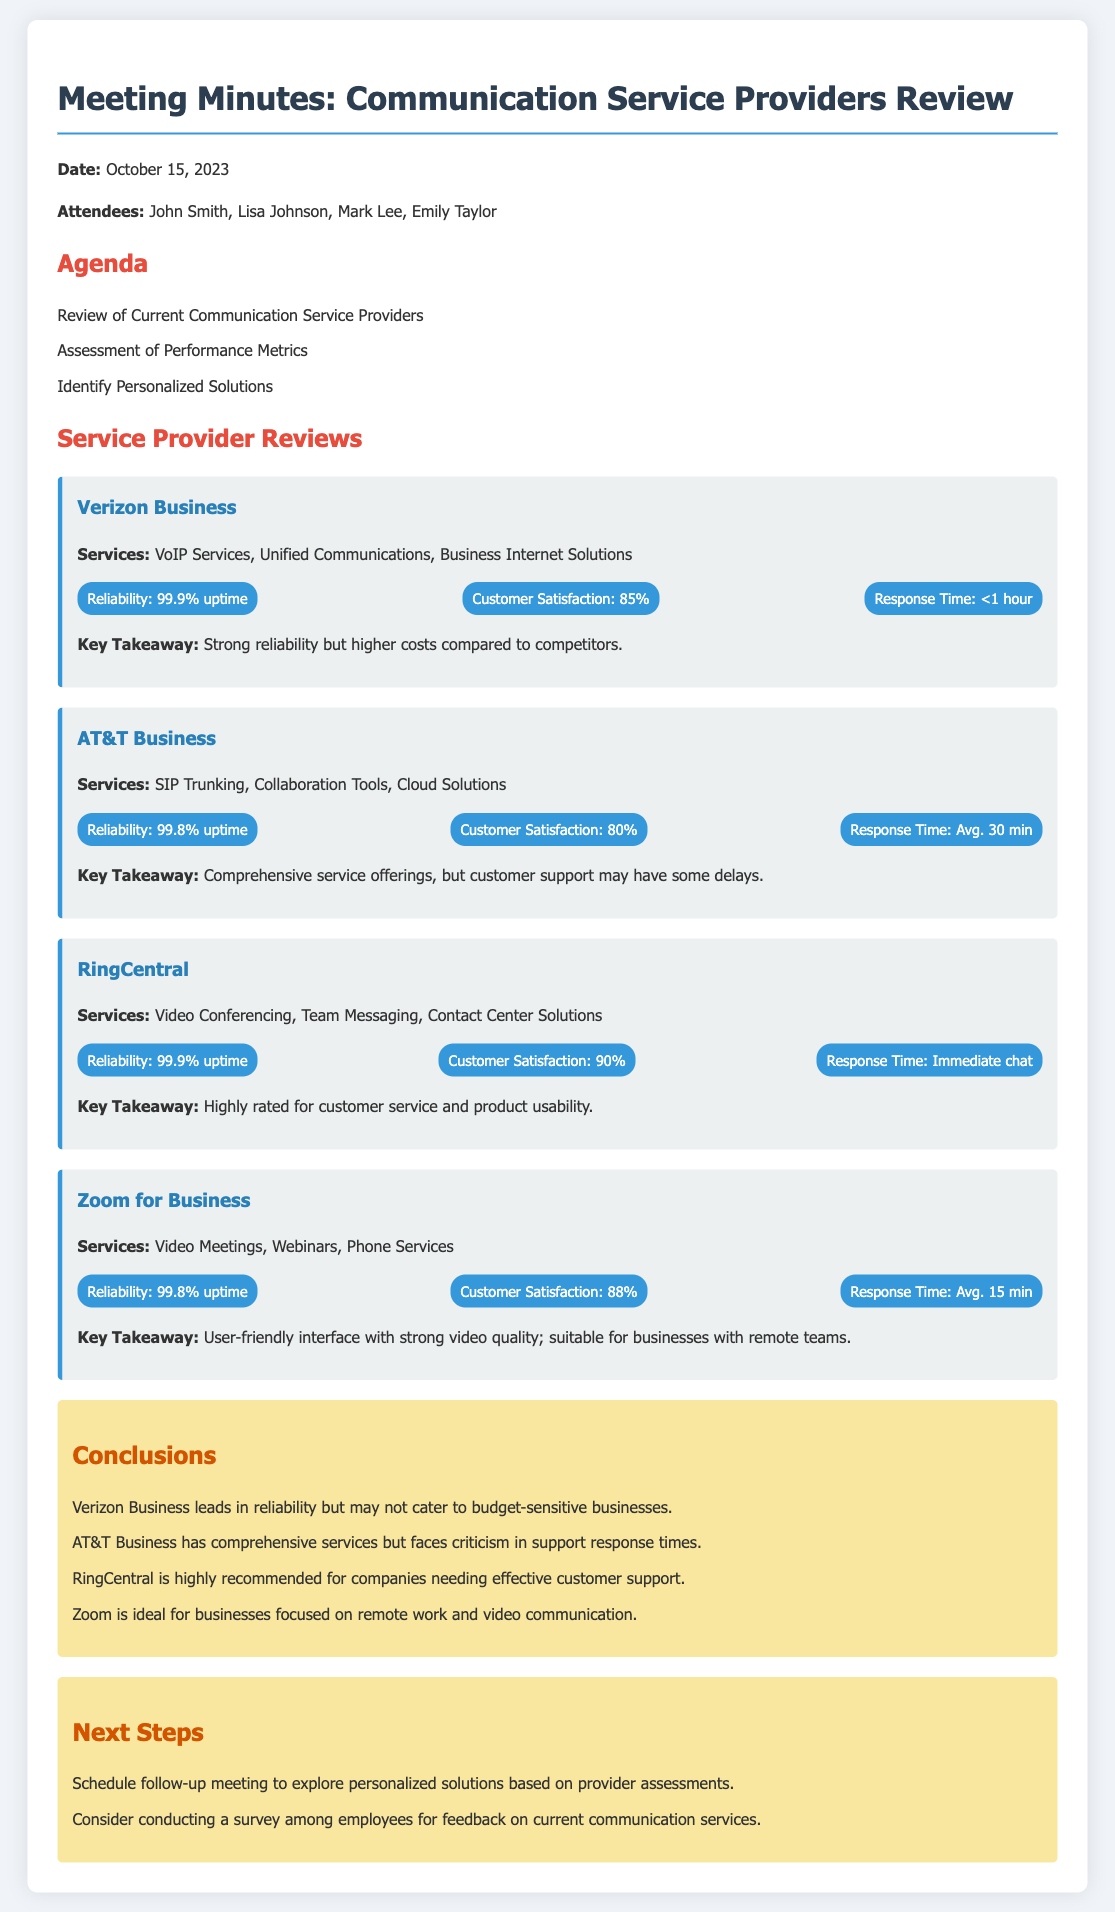What is the date of the meeting? The date of the meeting is stated at the beginning of the document.
Answer: October 15, 2023 Who attended the meeting? A list of attendees is provided in the document, indicating who was present during the meeting.
Answer: John Smith, Lisa Johnson, Mark Lee, Emily Taylor What service does RingCentral provide? The services offered by RingCentral are listed under its review section.
Answer: Video Conferencing, Team Messaging, Contact Center Solutions What is the reliability percentage of AT&T Business? The reliability metric for AT&T Business is explicitly mentioned in the document.
Answer: 99.8% uptime Which provider has the highest customer satisfaction? Customer satisfaction percentages are compared in the document to determine the highest score.
Answer: RingCentral What are the next steps mentioned? The document contains a section listing out the next steps after the meeting.
Answer: Schedule follow-up meeting, survey feedback What was a key takeaway for Zoom for Business? Key takeaways for each service provider are outlined in their respective sections.
Answer: User-friendly interface with strong video quality What is the reliability of Verizon Business? The reliability metric for Verizon Business is specifically stated in the document.
Answer: 99.9% uptime 